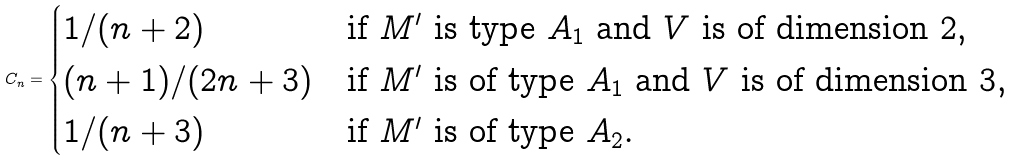<formula> <loc_0><loc_0><loc_500><loc_500>C _ { n } = \begin{cases} 1 / ( n + 2 ) & \text {if $M^{\prime}$ is type $A_{1}$ and $V$ is of               dimension $2$} , \\ ( n + 1 ) / ( 2 n + 3 ) & \text {if $M^{\prime}$ is of type $A_{1}$ and $V$                is of dimension $3$} , \\ 1 / ( n + 3 ) & \text {if $M^{\prime}$ is of type $A_{2}$} . \end{cases}</formula> 